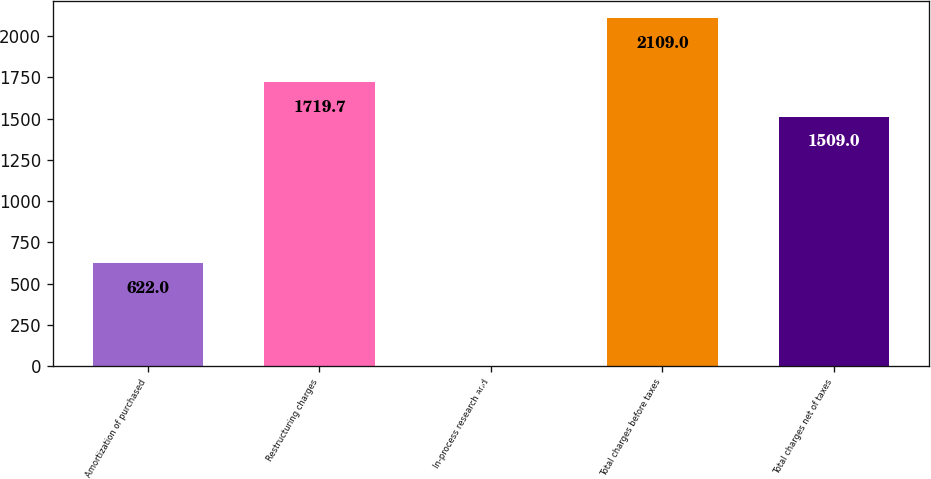Convert chart. <chart><loc_0><loc_0><loc_500><loc_500><bar_chart><fcel>Amortization of purchased<fcel>Restructuring charges<fcel>In-process research and<fcel>Total charges before taxes<fcel>Total charges net of taxes<nl><fcel>622<fcel>1719.7<fcel>2<fcel>2109<fcel>1509<nl></chart> 